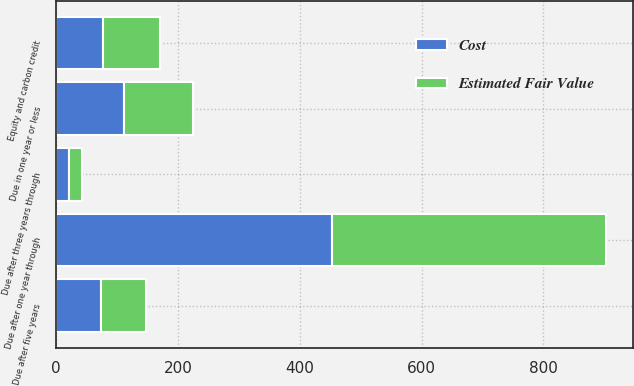Convert chart. <chart><loc_0><loc_0><loc_500><loc_500><stacked_bar_chart><ecel><fcel>Due in one year or less<fcel>Due after one year through<fcel>Due after three years through<fcel>Due after five years<fcel>Equity and carbon credit<nl><fcel>Cost<fcel>112<fcel>453<fcel>21<fcel>73<fcel>77<nl><fcel>Estimated Fair Value<fcel>112<fcel>449<fcel>21<fcel>74<fcel>93<nl></chart> 